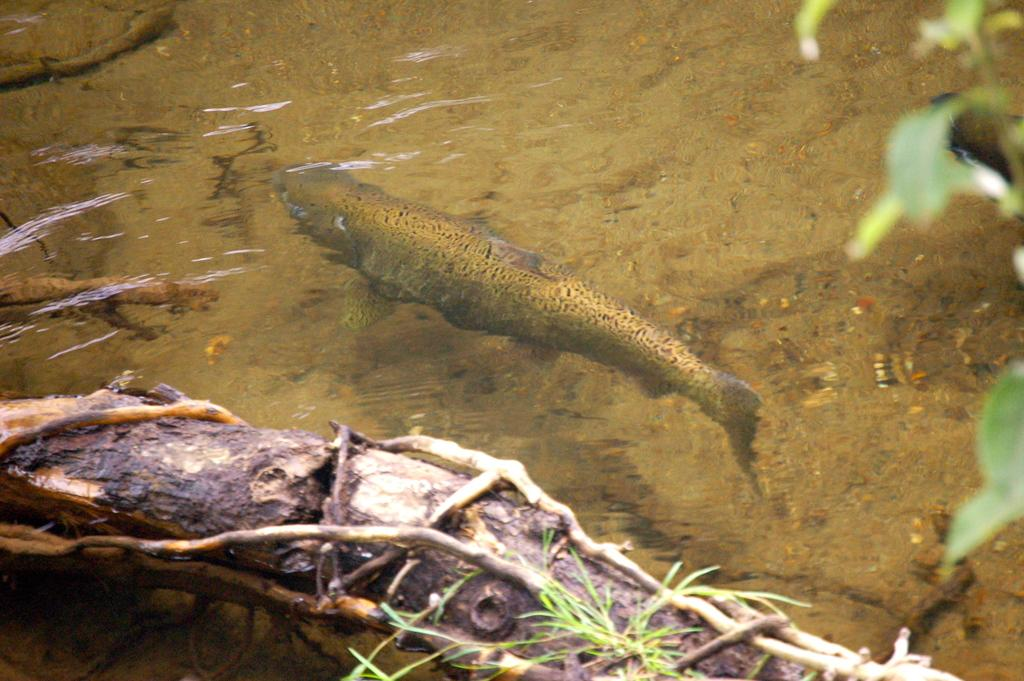What is the main subject of the image? There is a fish swimming in the water. What is located above the water surface? There is a wooden log above the water surface. What type of vegetation can be seen in the image? There is a plant on the right side of the image. What type of destruction can be seen in the image? There is no destruction present in the image; it features a fish swimming in the water, a wooden log, and a plant. How low is the sun in the image? The sun is not visible in the image, so it is not possible to determine its position or height. 